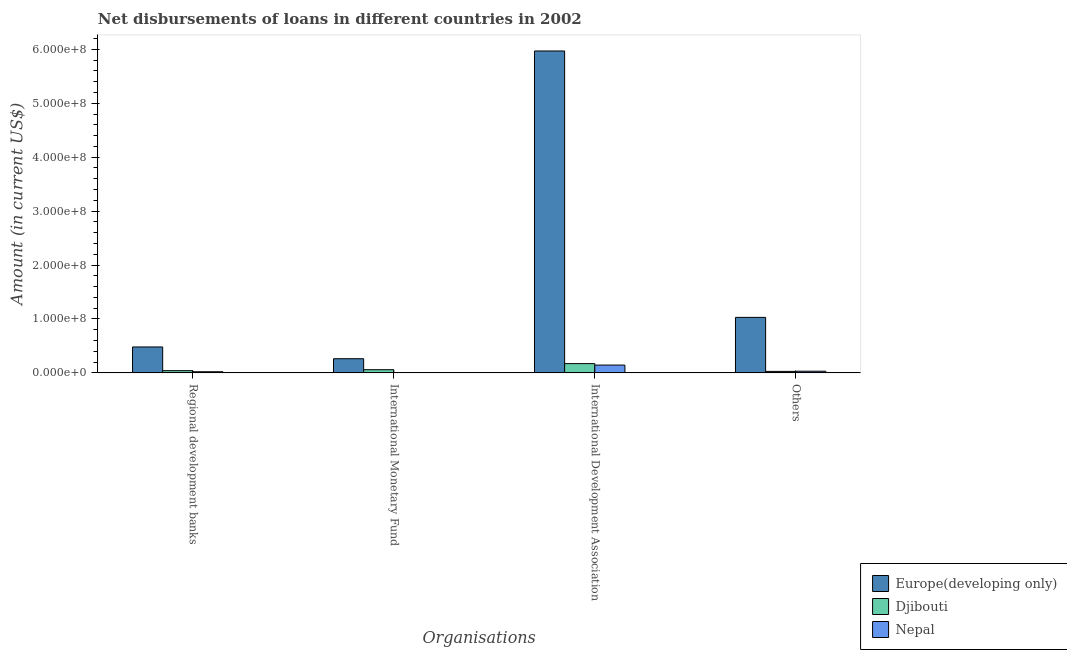How many different coloured bars are there?
Keep it short and to the point. 3. How many groups of bars are there?
Keep it short and to the point. 4. Are the number of bars per tick equal to the number of legend labels?
Provide a succinct answer. No. How many bars are there on the 3rd tick from the right?
Your answer should be very brief. 2. What is the label of the 2nd group of bars from the left?
Your answer should be very brief. International Monetary Fund. What is the amount of loan disimbursed by international development association in Europe(developing only)?
Make the answer very short. 5.97e+08. Across all countries, what is the maximum amount of loan disimbursed by international development association?
Make the answer very short. 5.97e+08. Across all countries, what is the minimum amount of loan disimbursed by regional development banks?
Ensure brevity in your answer.  2.09e+06. In which country was the amount of loan disimbursed by regional development banks maximum?
Your answer should be very brief. Europe(developing only). What is the total amount of loan disimbursed by international development association in the graph?
Offer a terse response. 6.29e+08. What is the difference between the amount of loan disimbursed by other organisations in Djibouti and that in Europe(developing only)?
Give a very brief answer. -1.00e+08. What is the difference between the amount of loan disimbursed by regional development banks in Nepal and the amount of loan disimbursed by international development association in Djibouti?
Your answer should be compact. -1.51e+07. What is the average amount of loan disimbursed by international development association per country?
Ensure brevity in your answer.  2.10e+08. What is the difference between the amount of loan disimbursed by other organisations and amount of loan disimbursed by international monetary fund in Europe(developing only)?
Make the answer very short. 7.67e+07. In how many countries, is the amount of loan disimbursed by international monetary fund greater than 500000000 US$?
Your answer should be compact. 0. What is the ratio of the amount of loan disimbursed by other organisations in Nepal to that in Djibouti?
Offer a very short reply. 1.13. What is the difference between the highest and the second highest amount of loan disimbursed by regional development banks?
Make the answer very short. 4.40e+07. What is the difference between the highest and the lowest amount of loan disimbursed by regional development banks?
Offer a very short reply. 4.60e+07. In how many countries, is the amount of loan disimbursed by international monetary fund greater than the average amount of loan disimbursed by international monetary fund taken over all countries?
Your answer should be very brief. 1. Is the sum of the amount of loan disimbursed by regional development banks in Nepal and Europe(developing only) greater than the maximum amount of loan disimbursed by other organisations across all countries?
Provide a succinct answer. No. Is it the case that in every country, the sum of the amount of loan disimbursed by other organisations and amount of loan disimbursed by international monetary fund is greater than the sum of amount of loan disimbursed by regional development banks and amount of loan disimbursed by international development association?
Your response must be concise. No. How many countries are there in the graph?
Offer a very short reply. 3. Does the graph contain any zero values?
Your response must be concise. Yes. Does the graph contain grids?
Make the answer very short. No. Where does the legend appear in the graph?
Your answer should be compact. Bottom right. How many legend labels are there?
Provide a succinct answer. 3. What is the title of the graph?
Keep it short and to the point. Net disbursements of loans in different countries in 2002. What is the label or title of the X-axis?
Provide a succinct answer. Organisations. What is the label or title of the Y-axis?
Your response must be concise. Amount (in current US$). What is the Amount (in current US$) in Europe(developing only) in Regional development banks?
Provide a short and direct response. 4.81e+07. What is the Amount (in current US$) of Djibouti in Regional development banks?
Make the answer very short. 4.10e+06. What is the Amount (in current US$) of Nepal in Regional development banks?
Offer a very short reply. 2.09e+06. What is the Amount (in current US$) of Europe(developing only) in International Monetary Fund?
Ensure brevity in your answer.  2.62e+07. What is the Amount (in current US$) in Djibouti in International Monetary Fund?
Offer a very short reply. 5.88e+06. What is the Amount (in current US$) in Nepal in International Monetary Fund?
Make the answer very short. 0. What is the Amount (in current US$) in Europe(developing only) in International Development Association?
Your answer should be very brief. 5.97e+08. What is the Amount (in current US$) in Djibouti in International Development Association?
Make the answer very short. 1.71e+07. What is the Amount (in current US$) of Nepal in International Development Association?
Ensure brevity in your answer.  1.45e+07. What is the Amount (in current US$) of Europe(developing only) in Others?
Make the answer very short. 1.03e+08. What is the Amount (in current US$) in Djibouti in Others?
Offer a very short reply. 2.71e+06. What is the Amount (in current US$) in Nepal in Others?
Offer a terse response. 3.07e+06. Across all Organisations, what is the maximum Amount (in current US$) in Europe(developing only)?
Ensure brevity in your answer.  5.97e+08. Across all Organisations, what is the maximum Amount (in current US$) of Djibouti?
Provide a short and direct response. 1.71e+07. Across all Organisations, what is the maximum Amount (in current US$) in Nepal?
Make the answer very short. 1.45e+07. Across all Organisations, what is the minimum Amount (in current US$) in Europe(developing only)?
Your answer should be compact. 2.62e+07. Across all Organisations, what is the minimum Amount (in current US$) in Djibouti?
Provide a succinct answer. 2.71e+06. Across all Organisations, what is the minimum Amount (in current US$) of Nepal?
Offer a very short reply. 0. What is the total Amount (in current US$) of Europe(developing only) in the graph?
Your answer should be compact. 7.74e+08. What is the total Amount (in current US$) of Djibouti in the graph?
Ensure brevity in your answer.  2.98e+07. What is the total Amount (in current US$) in Nepal in the graph?
Your answer should be compact. 1.96e+07. What is the difference between the Amount (in current US$) in Europe(developing only) in Regional development banks and that in International Monetary Fund?
Give a very brief answer. 2.18e+07. What is the difference between the Amount (in current US$) of Djibouti in Regional development banks and that in International Monetary Fund?
Your answer should be compact. -1.79e+06. What is the difference between the Amount (in current US$) of Europe(developing only) in Regional development banks and that in International Development Association?
Your answer should be compact. -5.49e+08. What is the difference between the Amount (in current US$) in Djibouti in Regional development banks and that in International Development Association?
Ensure brevity in your answer.  -1.30e+07. What is the difference between the Amount (in current US$) in Nepal in Regional development banks and that in International Development Association?
Provide a succinct answer. -1.24e+07. What is the difference between the Amount (in current US$) of Europe(developing only) in Regional development banks and that in Others?
Offer a very short reply. -5.49e+07. What is the difference between the Amount (in current US$) of Djibouti in Regional development banks and that in Others?
Your answer should be compact. 1.38e+06. What is the difference between the Amount (in current US$) of Nepal in Regional development banks and that in Others?
Make the answer very short. -9.84e+05. What is the difference between the Amount (in current US$) of Europe(developing only) in International Monetary Fund and that in International Development Association?
Your answer should be very brief. -5.71e+08. What is the difference between the Amount (in current US$) in Djibouti in International Monetary Fund and that in International Development Association?
Your answer should be very brief. -1.13e+07. What is the difference between the Amount (in current US$) in Europe(developing only) in International Monetary Fund and that in Others?
Provide a short and direct response. -7.67e+07. What is the difference between the Amount (in current US$) of Djibouti in International Monetary Fund and that in Others?
Offer a very short reply. 3.17e+06. What is the difference between the Amount (in current US$) in Europe(developing only) in International Development Association and that in Others?
Your answer should be compact. 4.94e+08. What is the difference between the Amount (in current US$) in Djibouti in International Development Association and that in Others?
Your response must be concise. 1.44e+07. What is the difference between the Amount (in current US$) in Nepal in International Development Association and that in Others?
Keep it short and to the point. 1.14e+07. What is the difference between the Amount (in current US$) in Europe(developing only) in Regional development banks and the Amount (in current US$) in Djibouti in International Monetary Fund?
Ensure brevity in your answer.  4.22e+07. What is the difference between the Amount (in current US$) of Europe(developing only) in Regional development banks and the Amount (in current US$) of Djibouti in International Development Association?
Keep it short and to the point. 3.09e+07. What is the difference between the Amount (in current US$) in Europe(developing only) in Regional development banks and the Amount (in current US$) in Nepal in International Development Association?
Offer a very short reply. 3.36e+07. What is the difference between the Amount (in current US$) of Djibouti in Regional development banks and the Amount (in current US$) of Nepal in International Development Association?
Provide a succinct answer. -1.04e+07. What is the difference between the Amount (in current US$) in Europe(developing only) in Regional development banks and the Amount (in current US$) in Djibouti in Others?
Provide a succinct answer. 4.53e+07. What is the difference between the Amount (in current US$) in Europe(developing only) in Regional development banks and the Amount (in current US$) in Nepal in Others?
Give a very brief answer. 4.50e+07. What is the difference between the Amount (in current US$) in Djibouti in Regional development banks and the Amount (in current US$) in Nepal in Others?
Offer a terse response. 1.02e+06. What is the difference between the Amount (in current US$) in Europe(developing only) in International Monetary Fund and the Amount (in current US$) in Djibouti in International Development Association?
Provide a short and direct response. 9.07e+06. What is the difference between the Amount (in current US$) of Europe(developing only) in International Monetary Fund and the Amount (in current US$) of Nepal in International Development Association?
Provide a short and direct response. 1.18e+07. What is the difference between the Amount (in current US$) in Djibouti in International Monetary Fund and the Amount (in current US$) in Nepal in International Development Association?
Ensure brevity in your answer.  -8.57e+06. What is the difference between the Amount (in current US$) in Europe(developing only) in International Monetary Fund and the Amount (in current US$) in Djibouti in Others?
Provide a short and direct response. 2.35e+07. What is the difference between the Amount (in current US$) of Europe(developing only) in International Monetary Fund and the Amount (in current US$) of Nepal in Others?
Offer a very short reply. 2.31e+07. What is the difference between the Amount (in current US$) of Djibouti in International Monetary Fund and the Amount (in current US$) of Nepal in Others?
Provide a succinct answer. 2.81e+06. What is the difference between the Amount (in current US$) of Europe(developing only) in International Development Association and the Amount (in current US$) of Djibouti in Others?
Provide a short and direct response. 5.94e+08. What is the difference between the Amount (in current US$) of Europe(developing only) in International Development Association and the Amount (in current US$) of Nepal in Others?
Offer a terse response. 5.94e+08. What is the difference between the Amount (in current US$) of Djibouti in International Development Association and the Amount (in current US$) of Nepal in Others?
Your response must be concise. 1.41e+07. What is the average Amount (in current US$) of Europe(developing only) per Organisations?
Provide a short and direct response. 1.94e+08. What is the average Amount (in current US$) of Djibouti per Organisations?
Provide a succinct answer. 7.46e+06. What is the average Amount (in current US$) in Nepal per Organisations?
Your answer should be compact. 4.90e+06. What is the difference between the Amount (in current US$) of Europe(developing only) and Amount (in current US$) of Djibouti in Regional development banks?
Make the answer very short. 4.40e+07. What is the difference between the Amount (in current US$) in Europe(developing only) and Amount (in current US$) in Nepal in Regional development banks?
Give a very brief answer. 4.60e+07. What is the difference between the Amount (in current US$) in Djibouti and Amount (in current US$) in Nepal in Regional development banks?
Provide a short and direct response. 2.01e+06. What is the difference between the Amount (in current US$) in Europe(developing only) and Amount (in current US$) in Djibouti in International Monetary Fund?
Your response must be concise. 2.03e+07. What is the difference between the Amount (in current US$) in Europe(developing only) and Amount (in current US$) in Djibouti in International Development Association?
Provide a short and direct response. 5.80e+08. What is the difference between the Amount (in current US$) in Europe(developing only) and Amount (in current US$) in Nepal in International Development Association?
Ensure brevity in your answer.  5.83e+08. What is the difference between the Amount (in current US$) of Djibouti and Amount (in current US$) of Nepal in International Development Association?
Provide a short and direct response. 2.69e+06. What is the difference between the Amount (in current US$) of Europe(developing only) and Amount (in current US$) of Djibouti in Others?
Provide a short and direct response. 1.00e+08. What is the difference between the Amount (in current US$) in Europe(developing only) and Amount (in current US$) in Nepal in Others?
Make the answer very short. 9.98e+07. What is the difference between the Amount (in current US$) in Djibouti and Amount (in current US$) in Nepal in Others?
Provide a succinct answer. -3.60e+05. What is the ratio of the Amount (in current US$) of Europe(developing only) in Regional development banks to that in International Monetary Fund?
Offer a very short reply. 1.83. What is the ratio of the Amount (in current US$) of Djibouti in Regional development banks to that in International Monetary Fund?
Your answer should be compact. 0.7. What is the ratio of the Amount (in current US$) in Europe(developing only) in Regional development banks to that in International Development Association?
Offer a very short reply. 0.08. What is the ratio of the Amount (in current US$) of Djibouti in Regional development banks to that in International Development Association?
Make the answer very short. 0.24. What is the ratio of the Amount (in current US$) in Nepal in Regional development banks to that in International Development Association?
Keep it short and to the point. 0.14. What is the ratio of the Amount (in current US$) in Europe(developing only) in Regional development banks to that in Others?
Offer a terse response. 0.47. What is the ratio of the Amount (in current US$) of Djibouti in Regional development banks to that in Others?
Offer a terse response. 1.51. What is the ratio of the Amount (in current US$) in Nepal in Regional development banks to that in Others?
Ensure brevity in your answer.  0.68. What is the ratio of the Amount (in current US$) in Europe(developing only) in International Monetary Fund to that in International Development Association?
Offer a terse response. 0.04. What is the ratio of the Amount (in current US$) of Djibouti in International Monetary Fund to that in International Development Association?
Ensure brevity in your answer.  0.34. What is the ratio of the Amount (in current US$) of Europe(developing only) in International Monetary Fund to that in Others?
Your answer should be compact. 0.25. What is the ratio of the Amount (in current US$) in Djibouti in International Monetary Fund to that in Others?
Your answer should be compact. 2.17. What is the ratio of the Amount (in current US$) in Europe(developing only) in International Development Association to that in Others?
Your answer should be compact. 5.8. What is the ratio of the Amount (in current US$) in Djibouti in International Development Association to that in Others?
Your response must be concise. 6.32. What is the ratio of the Amount (in current US$) in Nepal in International Development Association to that in Others?
Your answer should be very brief. 4.7. What is the difference between the highest and the second highest Amount (in current US$) in Europe(developing only)?
Offer a very short reply. 4.94e+08. What is the difference between the highest and the second highest Amount (in current US$) of Djibouti?
Offer a terse response. 1.13e+07. What is the difference between the highest and the second highest Amount (in current US$) of Nepal?
Keep it short and to the point. 1.14e+07. What is the difference between the highest and the lowest Amount (in current US$) of Europe(developing only)?
Make the answer very short. 5.71e+08. What is the difference between the highest and the lowest Amount (in current US$) of Djibouti?
Your answer should be compact. 1.44e+07. What is the difference between the highest and the lowest Amount (in current US$) in Nepal?
Ensure brevity in your answer.  1.45e+07. 